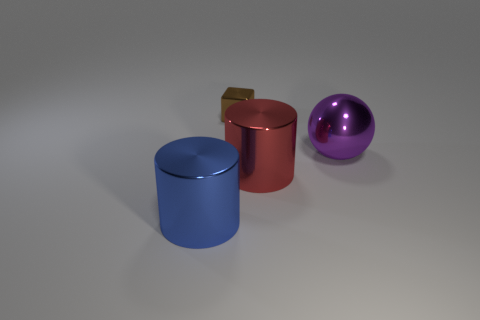Add 2 purple objects. How many objects exist? 6 Subtract all spheres. How many objects are left? 3 Subtract all red cylinders. How many cylinders are left? 1 Subtract 1 blocks. How many blocks are left? 0 Add 2 cylinders. How many cylinders are left? 4 Add 1 large yellow rubber things. How many large yellow rubber things exist? 1 Subtract 0 brown spheres. How many objects are left? 4 Subtract all cyan balls. Subtract all cyan cubes. How many balls are left? 1 Subtract all small green shiny cylinders. Subtract all cylinders. How many objects are left? 2 